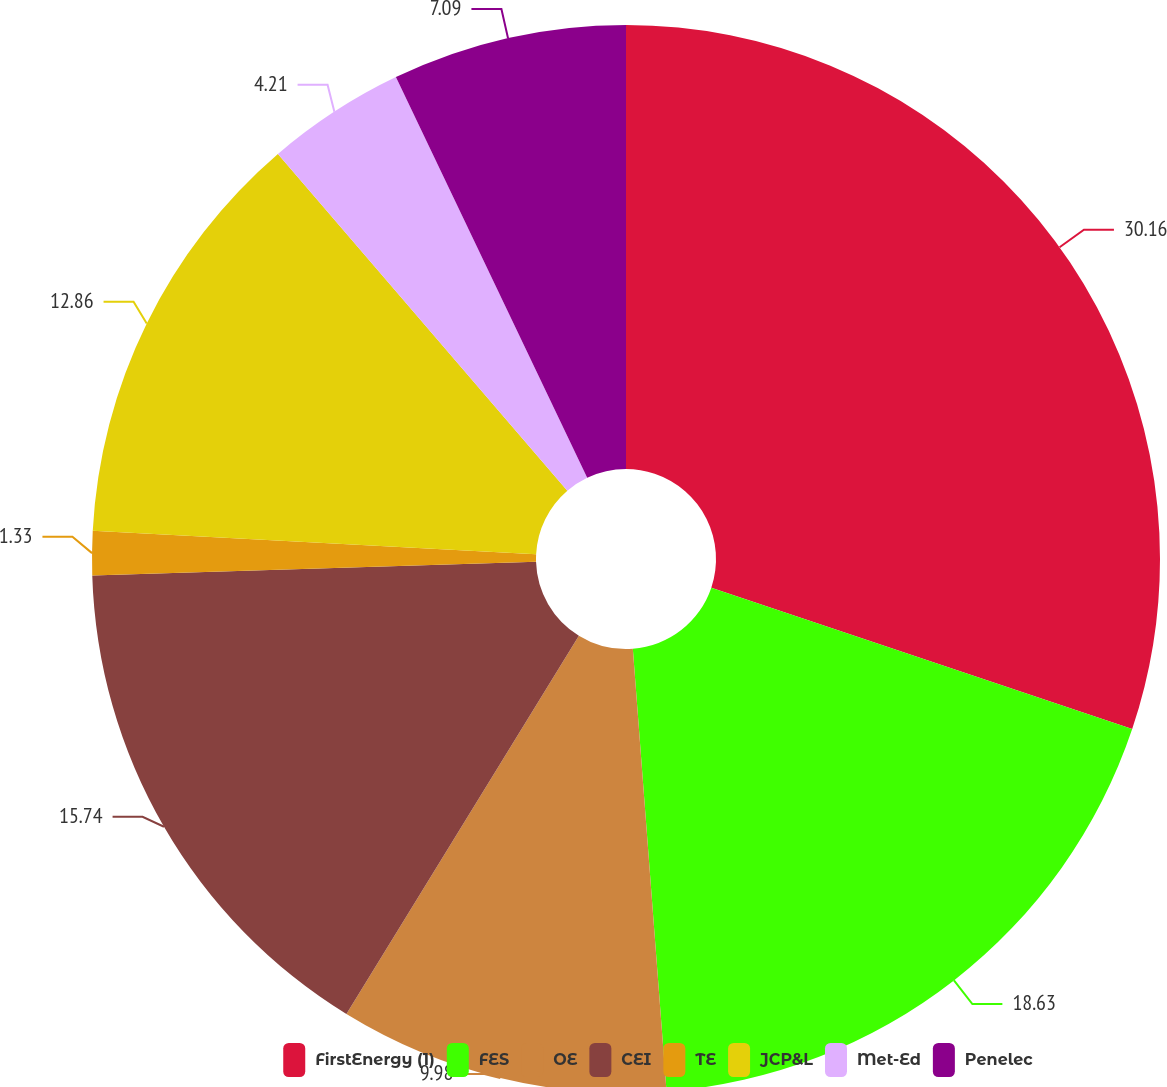Convert chart. <chart><loc_0><loc_0><loc_500><loc_500><pie_chart><fcel>FirstEnergy (1)<fcel>FES<fcel>OE<fcel>CEI<fcel>TE<fcel>JCP&L<fcel>Met-Ed<fcel>Penelec<nl><fcel>30.16%<fcel>18.63%<fcel>9.98%<fcel>15.74%<fcel>1.33%<fcel>12.86%<fcel>4.21%<fcel>7.09%<nl></chart> 